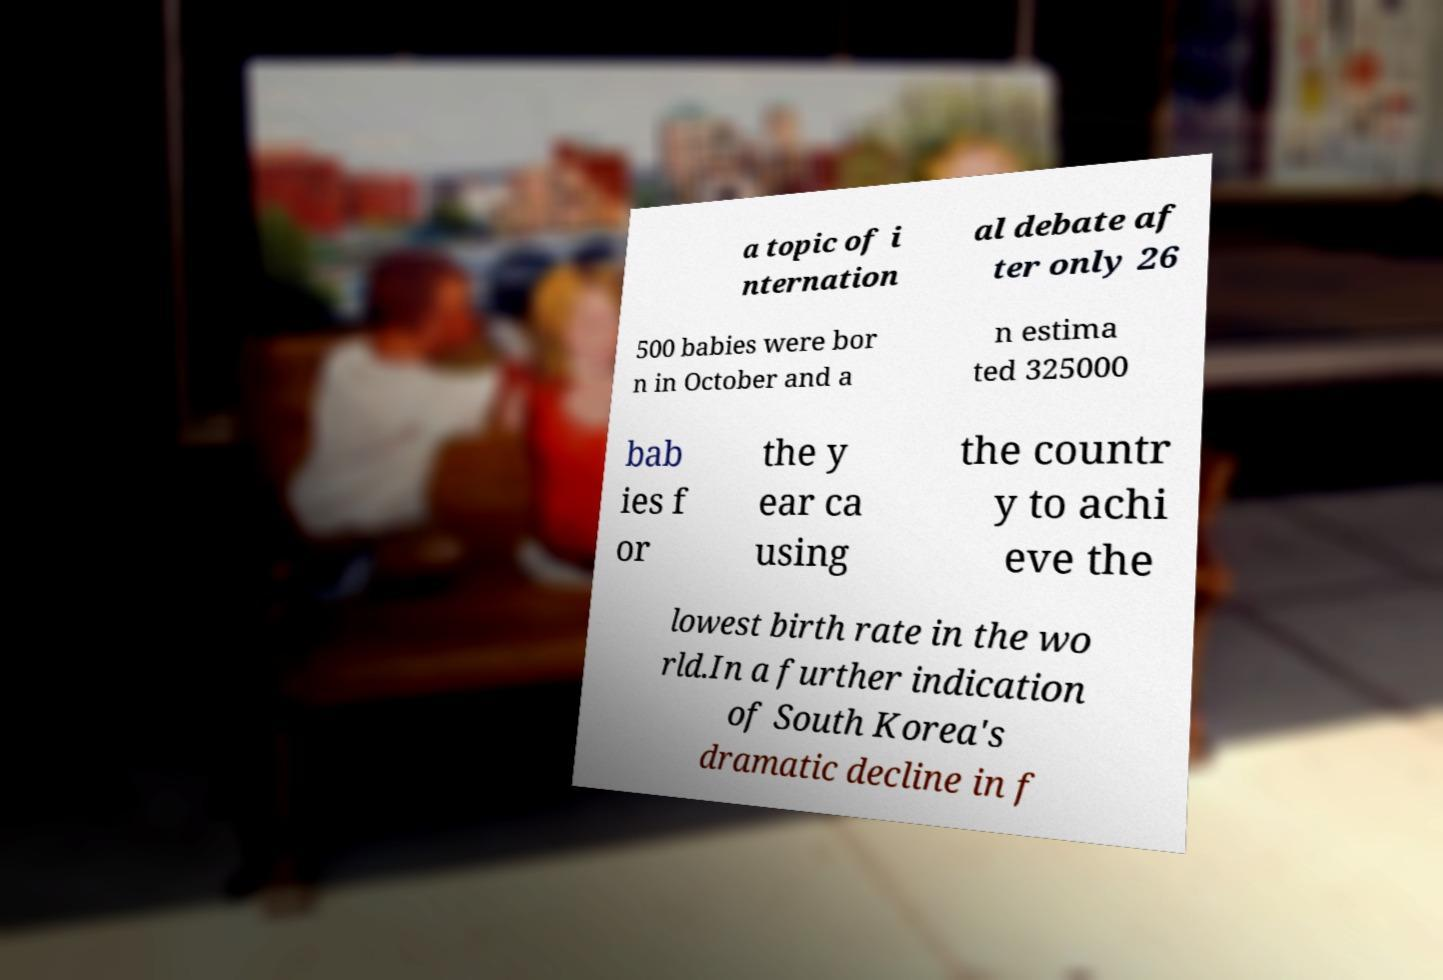What messages or text are displayed in this image? I need them in a readable, typed format. a topic of i nternation al debate af ter only 26 500 babies were bor n in October and a n estima ted 325000 bab ies f or the y ear ca using the countr y to achi eve the lowest birth rate in the wo rld.In a further indication of South Korea's dramatic decline in f 